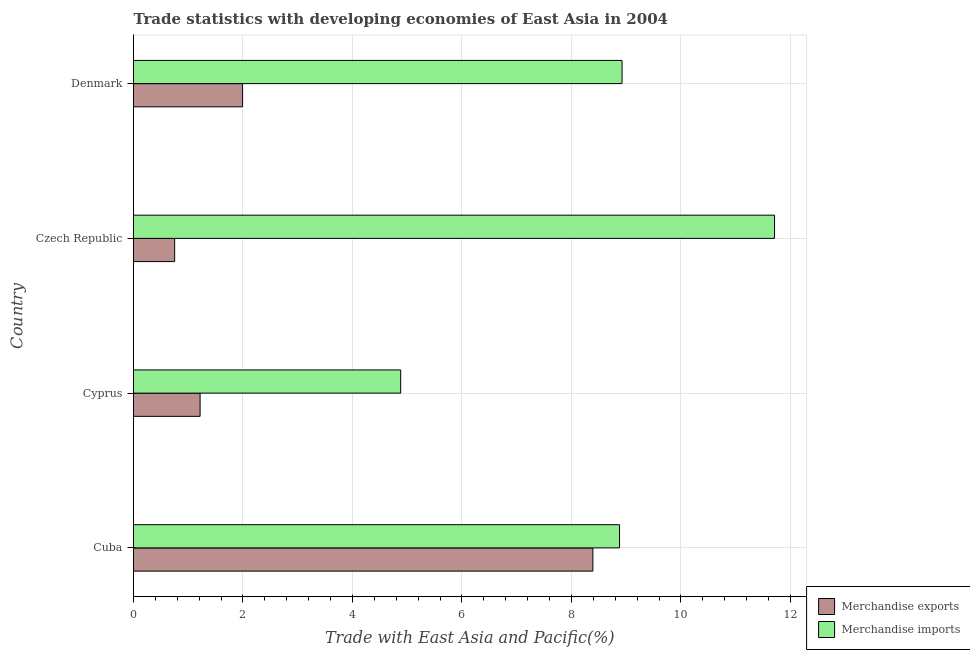How many bars are there on the 2nd tick from the bottom?
Your response must be concise. 2. What is the label of the 3rd group of bars from the top?
Keep it short and to the point. Cyprus. What is the merchandise exports in Cuba?
Give a very brief answer. 8.39. Across all countries, what is the maximum merchandise exports?
Offer a terse response. 8.39. Across all countries, what is the minimum merchandise imports?
Your answer should be very brief. 4.88. In which country was the merchandise imports maximum?
Offer a terse response. Czech Republic. In which country was the merchandise exports minimum?
Your answer should be compact. Czech Republic. What is the total merchandise exports in the graph?
Provide a short and direct response. 12.35. What is the difference between the merchandise exports in Cyprus and that in Czech Republic?
Your response must be concise. 0.47. What is the difference between the merchandise imports in Czech Republic and the merchandise exports in Cuba?
Offer a very short reply. 3.32. What is the average merchandise imports per country?
Your answer should be compact. 8.6. What is the difference between the merchandise exports and merchandise imports in Cuba?
Your response must be concise. -0.49. What is the ratio of the merchandise imports in Cuba to that in Czech Republic?
Offer a very short reply. 0.76. Is the merchandise imports in Cuba less than that in Denmark?
Offer a very short reply. Yes. What is the difference between the highest and the second highest merchandise exports?
Keep it short and to the point. 6.4. What is the difference between the highest and the lowest merchandise exports?
Ensure brevity in your answer.  7.64. In how many countries, is the merchandise imports greater than the average merchandise imports taken over all countries?
Provide a short and direct response. 3. What does the 1st bar from the top in Cuba represents?
Keep it short and to the point. Merchandise imports. Are all the bars in the graph horizontal?
Offer a very short reply. Yes. How many countries are there in the graph?
Provide a succinct answer. 4. Where does the legend appear in the graph?
Keep it short and to the point. Bottom right. How are the legend labels stacked?
Provide a succinct answer. Vertical. What is the title of the graph?
Give a very brief answer. Trade statistics with developing economies of East Asia in 2004. Does "Merchandise imports" appear as one of the legend labels in the graph?
Make the answer very short. Yes. What is the label or title of the X-axis?
Offer a terse response. Trade with East Asia and Pacific(%). What is the label or title of the Y-axis?
Ensure brevity in your answer.  Country. What is the Trade with East Asia and Pacific(%) of Merchandise exports in Cuba?
Offer a terse response. 8.39. What is the Trade with East Asia and Pacific(%) of Merchandise imports in Cuba?
Your answer should be very brief. 8.88. What is the Trade with East Asia and Pacific(%) in Merchandise exports in Cyprus?
Ensure brevity in your answer.  1.22. What is the Trade with East Asia and Pacific(%) in Merchandise imports in Cyprus?
Make the answer very short. 4.88. What is the Trade with East Asia and Pacific(%) in Merchandise exports in Czech Republic?
Your answer should be compact. 0.75. What is the Trade with East Asia and Pacific(%) of Merchandise imports in Czech Republic?
Provide a short and direct response. 11.71. What is the Trade with East Asia and Pacific(%) in Merchandise exports in Denmark?
Your answer should be very brief. 1.99. What is the Trade with East Asia and Pacific(%) in Merchandise imports in Denmark?
Make the answer very short. 8.92. Across all countries, what is the maximum Trade with East Asia and Pacific(%) of Merchandise exports?
Offer a terse response. 8.39. Across all countries, what is the maximum Trade with East Asia and Pacific(%) of Merchandise imports?
Offer a terse response. 11.71. Across all countries, what is the minimum Trade with East Asia and Pacific(%) of Merchandise exports?
Your answer should be very brief. 0.75. Across all countries, what is the minimum Trade with East Asia and Pacific(%) in Merchandise imports?
Give a very brief answer. 4.88. What is the total Trade with East Asia and Pacific(%) in Merchandise exports in the graph?
Your answer should be very brief. 12.35. What is the total Trade with East Asia and Pacific(%) of Merchandise imports in the graph?
Make the answer very short. 34.4. What is the difference between the Trade with East Asia and Pacific(%) in Merchandise exports in Cuba and that in Cyprus?
Give a very brief answer. 7.18. What is the difference between the Trade with East Asia and Pacific(%) in Merchandise imports in Cuba and that in Cyprus?
Provide a short and direct response. 4. What is the difference between the Trade with East Asia and Pacific(%) of Merchandise exports in Cuba and that in Czech Republic?
Provide a succinct answer. 7.64. What is the difference between the Trade with East Asia and Pacific(%) in Merchandise imports in Cuba and that in Czech Republic?
Offer a very short reply. -2.83. What is the difference between the Trade with East Asia and Pacific(%) in Merchandise exports in Cuba and that in Denmark?
Keep it short and to the point. 6.4. What is the difference between the Trade with East Asia and Pacific(%) of Merchandise imports in Cuba and that in Denmark?
Ensure brevity in your answer.  -0.05. What is the difference between the Trade with East Asia and Pacific(%) in Merchandise exports in Cyprus and that in Czech Republic?
Keep it short and to the point. 0.46. What is the difference between the Trade with East Asia and Pacific(%) of Merchandise imports in Cyprus and that in Czech Republic?
Provide a succinct answer. -6.83. What is the difference between the Trade with East Asia and Pacific(%) in Merchandise exports in Cyprus and that in Denmark?
Your response must be concise. -0.78. What is the difference between the Trade with East Asia and Pacific(%) of Merchandise imports in Cyprus and that in Denmark?
Your answer should be very brief. -4.04. What is the difference between the Trade with East Asia and Pacific(%) in Merchandise exports in Czech Republic and that in Denmark?
Your answer should be very brief. -1.24. What is the difference between the Trade with East Asia and Pacific(%) of Merchandise imports in Czech Republic and that in Denmark?
Make the answer very short. 2.79. What is the difference between the Trade with East Asia and Pacific(%) in Merchandise exports in Cuba and the Trade with East Asia and Pacific(%) in Merchandise imports in Cyprus?
Offer a very short reply. 3.51. What is the difference between the Trade with East Asia and Pacific(%) in Merchandise exports in Cuba and the Trade with East Asia and Pacific(%) in Merchandise imports in Czech Republic?
Your answer should be very brief. -3.32. What is the difference between the Trade with East Asia and Pacific(%) in Merchandise exports in Cuba and the Trade with East Asia and Pacific(%) in Merchandise imports in Denmark?
Give a very brief answer. -0.53. What is the difference between the Trade with East Asia and Pacific(%) in Merchandise exports in Cyprus and the Trade with East Asia and Pacific(%) in Merchandise imports in Czech Republic?
Offer a very short reply. -10.49. What is the difference between the Trade with East Asia and Pacific(%) in Merchandise exports in Cyprus and the Trade with East Asia and Pacific(%) in Merchandise imports in Denmark?
Your response must be concise. -7.71. What is the difference between the Trade with East Asia and Pacific(%) in Merchandise exports in Czech Republic and the Trade with East Asia and Pacific(%) in Merchandise imports in Denmark?
Ensure brevity in your answer.  -8.17. What is the average Trade with East Asia and Pacific(%) of Merchandise exports per country?
Provide a succinct answer. 3.09. What is the average Trade with East Asia and Pacific(%) of Merchandise imports per country?
Your answer should be compact. 8.6. What is the difference between the Trade with East Asia and Pacific(%) of Merchandise exports and Trade with East Asia and Pacific(%) of Merchandise imports in Cuba?
Offer a terse response. -0.49. What is the difference between the Trade with East Asia and Pacific(%) of Merchandise exports and Trade with East Asia and Pacific(%) of Merchandise imports in Cyprus?
Your response must be concise. -3.66. What is the difference between the Trade with East Asia and Pacific(%) in Merchandise exports and Trade with East Asia and Pacific(%) in Merchandise imports in Czech Republic?
Your answer should be compact. -10.96. What is the difference between the Trade with East Asia and Pacific(%) in Merchandise exports and Trade with East Asia and Pacific(%) in Merchandise imports in Denmark?
Provide a short and direct response. -6.93. What is the ratio of the Trade with East Asia and Pacific(%) of Merchandise exports in Cuba to that in Cyprus?
Your answer should be very brief. 6.9. What is the ratio of the Trade with East Asia and Pacific(%) in Merchandise imports in Cuba to that in Cyprus?
Provide a short and direct response. 1.82. What is the ratio of the Trade with East Asia and Pacific(%) in Merchandise exports in Cuba to that in Czech Republic?
Provide a short and direct response. 11.17. What is the ratio of the Trade with East Asia and Pacific(%) of Merchandise imports in Cuba to that in Czech Republic?
Your answer should be very brief. 0.76. What is the ratio of the Trade with East Asia and Pacific(%) of Merchandise exports in Cuba to that in Denmark?
Provide a short and direct response. 4.21. What is the ratio of the Trade with East Asia and Pacific(%) in Merchandise exports in Cyprus to that in Czech Republic?
Keep it short and to the point. 1.62. What is the ratio of the Trade with East Asia and Pacific(%) in Merchandise imports in Cyprus to that in Czech Republic?
Provide a short and direct response. 0.42. What is the ratio of the Trade with East Asia and Pacific(%) in Merchandise exports in Cyprus to that in Denmark?
Make the answer very short. 0.61. What is the ratio of the Trade with East Asia and Pacific(%) of Merchandise imports in Cyprus to that in Denmark?
Your answer should be very brief. 0.55. What is the ratio of the Trade with East Asia and Pacific(%) in Merchandise exports in Czech Republic to that in Denmark?
Your response must be concise. 0.38. What is the ratio of the Trade with East Asia and Pacific(%) of Merchandise imports in Czech Republic to that in Denmark?
Make the answer very short. 1.31. What is the difference between the highest and the second highest Trade with East Asia and Pacific(%) of Merchandise exports?
Make the answer very short. 6.4. What is the difference between the highest and the second highest Trade with East Asia and Pacific(%) of Merchandise imports?
Your response must be concise. 2.79. What is the difference between the highest and the lowest Trade with East Asia and Pacific(%) of Merchandise exports?
Your answer should be compact. 7.64. What is the difference between the highest and the lowest Trade with East Asia and Pacific(%) of Merchandise imports?
Provide a succinct answer. 6.83. 